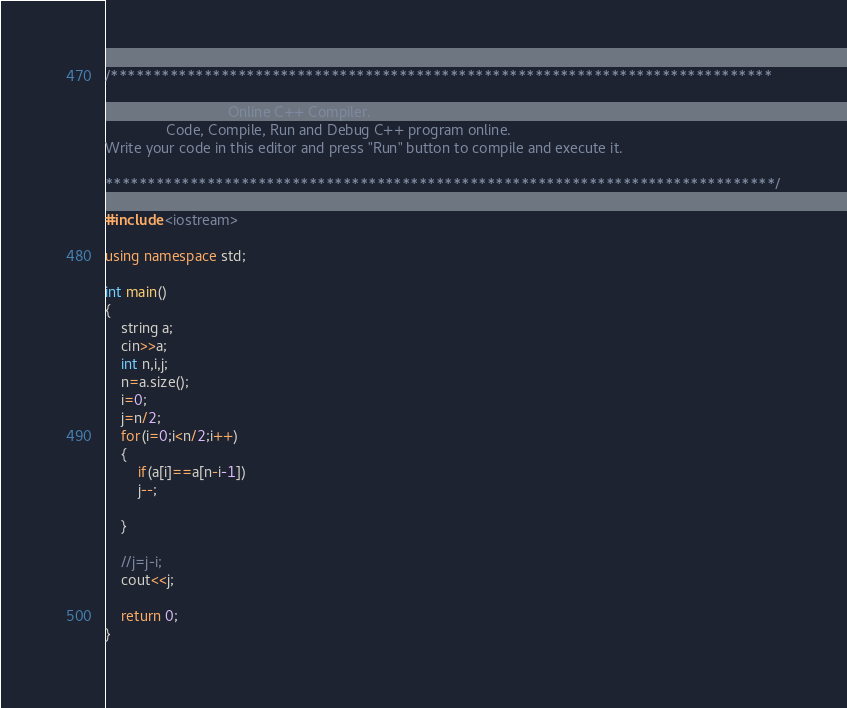Convert code to text. <code><loc_0><loc_0><loc_500><loc_500><_C++_>/******************************************************************************

                              Online C++ Compiler.
               Code, Compile, Run and Debug C++ program online.
Write your code in this editor and press "Run" button to compile and execute it.

*******************************************************************************/

#include <iostream>

using namespace std;

int main()
{
    string a;
    cin>>a;
    int n,i,j;
    n=a.size();
    i=0;
    j=n/2;
    for(i=0;i<n/2;i++)
    {
        if(a[i]==a[n-i-1])
        j--;
        
    }
    
    //j=j-i;
    cout<<j;

    return 0;
}
</code> 